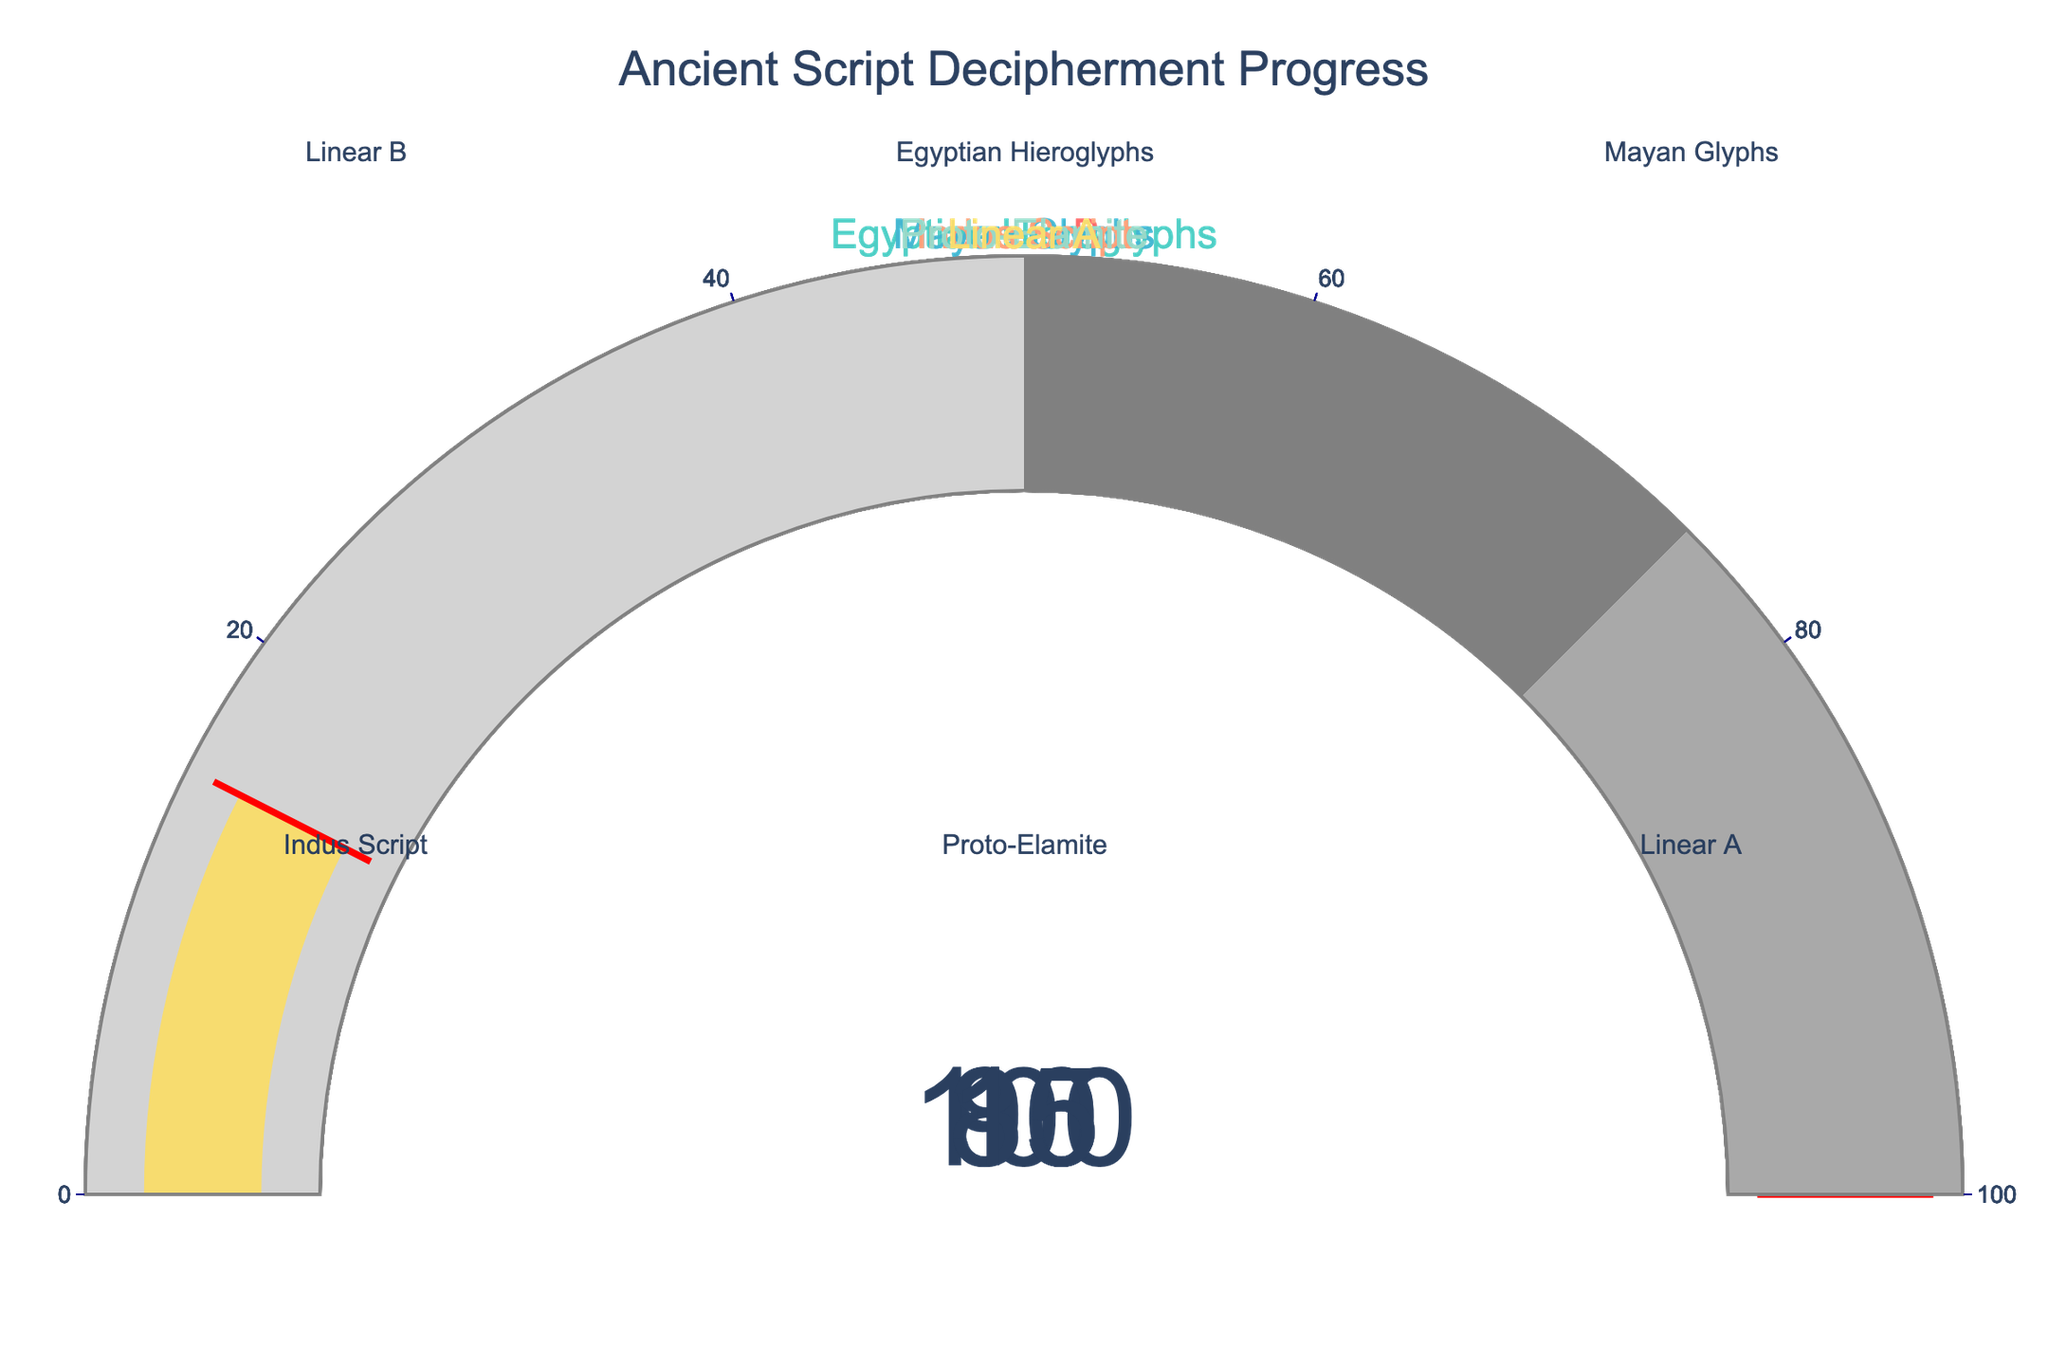Which ancient script shows the highest decipherment percentage? The gauge for Egyptian Hieroglyphs shows 100%, which is the highest decipherment percentage among all scripts displayed.
Answer: Egyptian Hieroglyphs What is the decipherment percentage of the Indus Script? Refer to the gauge labeled Indus Script; it shows a decipherment percentage of 10%.
Answer: 10% Which script has a decipherment percentage of 95%? The gauge for Linear B shows a decipherment percentage of 95%.
Answer: Linear B How much higher is the decipherment percentage of Mayan Glyphs compared to Linear A? Compare the percentages on the gauges: Mayan Glyphs are at 85% and Linear A is at 15%. The difference is 85% - 15% = 70%.
Answer: 70% Is Proto-Elamite more or less deciphered than the Indus Script? Compare the gauges: Proto-Elamite has a 30% decipherment, whereas Indus Script has 10%. So, Proto-Elamite is more deciphered.
Answer: More What's the average decipherment percentage for the three most deciphered scripts? The three most deciphered scripts are Egyptian Hieroglyphs (100%), Linear B (95%), and Mayan Glyphs (85%). The average is (100 + 95 + 85) / 3 = 93.33%.
Answer: 93.33% By how much does the decipherment of Linear A lag behind Proto-Elamite? Proto-Elamite's decipherment is 30%, and Linear A's is 15%. The difference is 30% - 15% = 15%.
Answer: 15% Which script has the lowest decipherment percentage? The gauge showing the lowest decipherment percentage belongs to the Indus Script with 10%.
Answer: Indus Script Rank the scripts from most to least deciphered. From the gauges: Egyptian Hieroglyphs (100%), Linear B (95%), Mayan Glyphs (85%), Proto-Elamite (30%), Linear A (15%), Indus Script (10%).
Answer: Egyptian Hieroglyphs > Linear B > Mayan Glyphs > Proto-Elamite > Linear A > Indus Script What percentage of decipherment is needed for Linear A to reach the level of Mayan Glyphs? Mayan Glyphs are deciphered at 85% and Linear A at 15%. The required increase is 85% - 15% = 70%.
Answer: 70% 